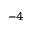<formula> <loc_0><loc_0><loc_500><loc_500>^ { - 4 }</formula> 